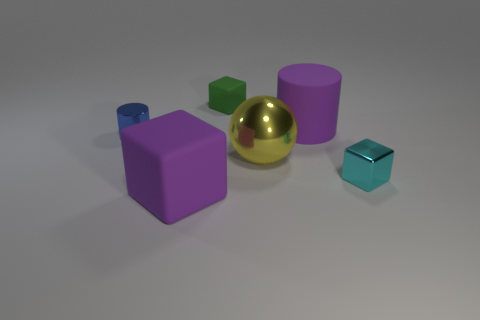What's the lighting source in this scene? The shadows and reflections on the objects suggest that there is a diffused, overhead light source in the scene, likely placed above and slightly to the front of the objects, providing a soft illumination without harsh shadows. Could these objects be part of a game or are they purely decorative? These objects may well serve a decorative purpose, given their varied colors and shapes, which could add aesthetic appeal to an environment. However, their geometric shapes and distinct colors also suggest they could be part of an educational game or toy set, aimed at teaching concepts such as sorting, building, or color identification for learning purposes. 